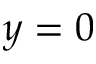<formula> <loc_0><loc_0><loc_500><loc_500>y = 0</formula> 